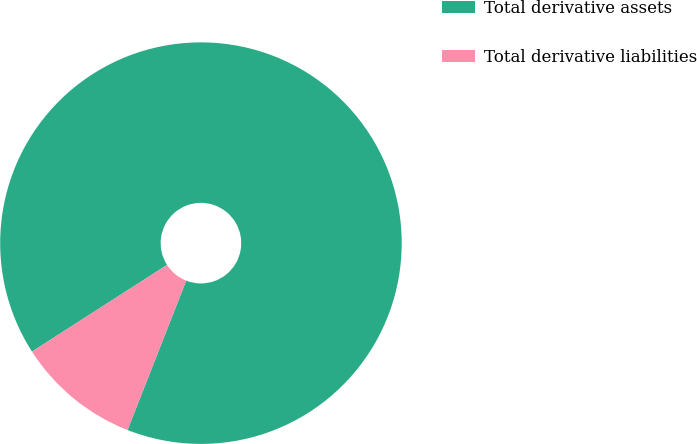<chart> <loc_0><loc_0><loc_500><loc_500><pie_chart><fcel>Total derivative assets<fcel>Total derivative liabilities<nl><fcel>90.04%<fcel>9.96%<nl></chart> 